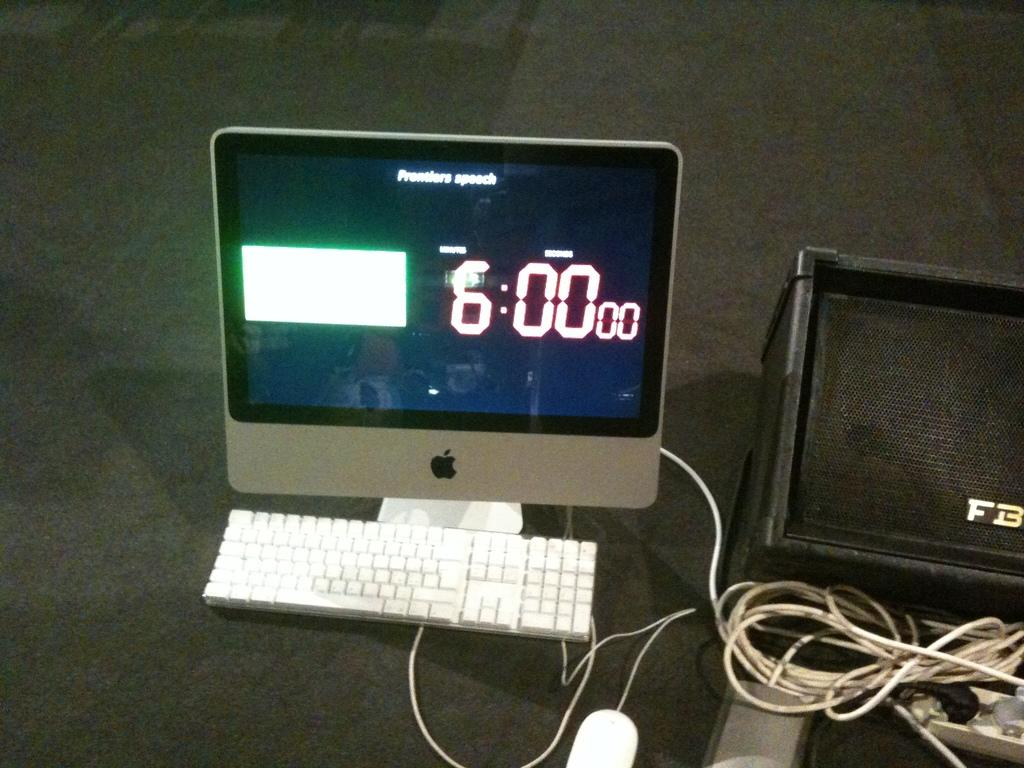<image>
Offer a succinct explanation of the picture presented. Apple monitor that shows the time at 6:00. 